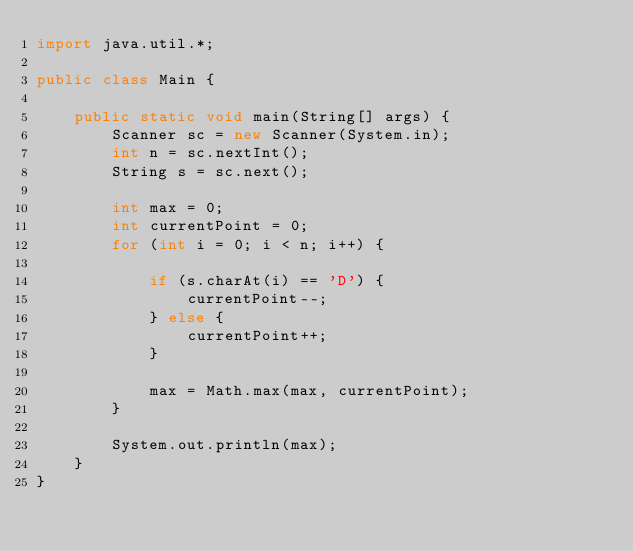<code> <loc_0><loc_0><loc_500><loc_500><_Java_>import java.util.*;

public class Main {

    public static void main(String[] args) {
        Scanner sc = new Scanner(System.in);
        int n = sc.nextInt();
        String s = sc.next();

        int max = 0;
        int currentPoint = 0;
        for (int i = 0; i < n; i++) {

            if (s.charAt(i) == 'D') {
                currentPoint--;
            } else {
                currentPoint++;
            }

            max = Math.max(max, currentPoint);
        }

        System.out.println(max);
    }
}
</code> 